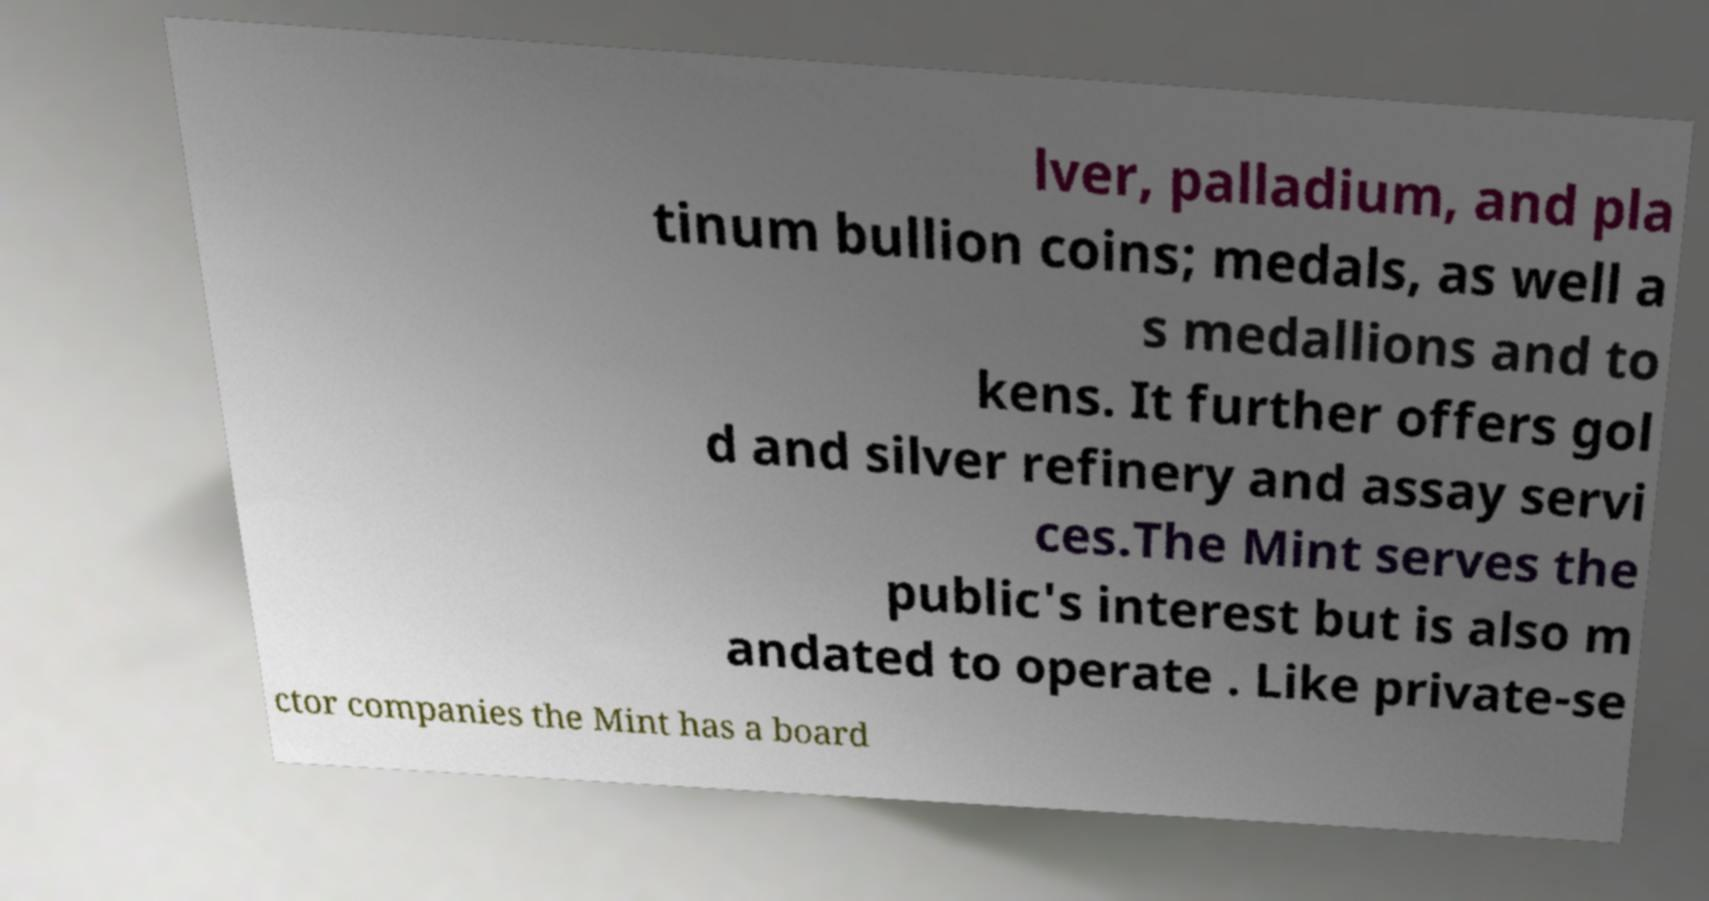Can you accurately transcribe the text from the provided image for me? lver, palladium, and pla tinum bullion coins; medals, as well a s medallions and to kens. It further offers gol d and silver refinery and assay servi ces.The Mint serves the public's interest but is also m andated to operate . Like private-se ctor companies the Mint has a board 